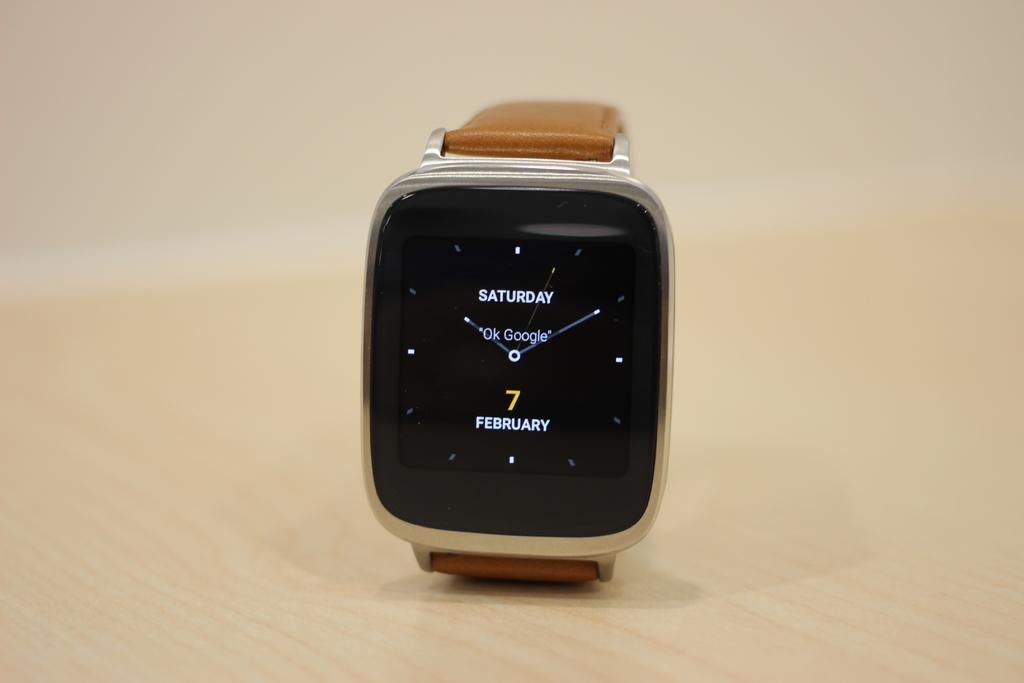Provide a one-sentence caption for the provided image. A smart watch says Saturday 7 February and is on a wooden table. 